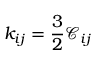Convert formula to latex. <formula><loc_0><loc_0><loc_500><loc_500>k _ { i j } = \frac { 3 } { 2 } \mathcal { C } _ { i j }</formula> 